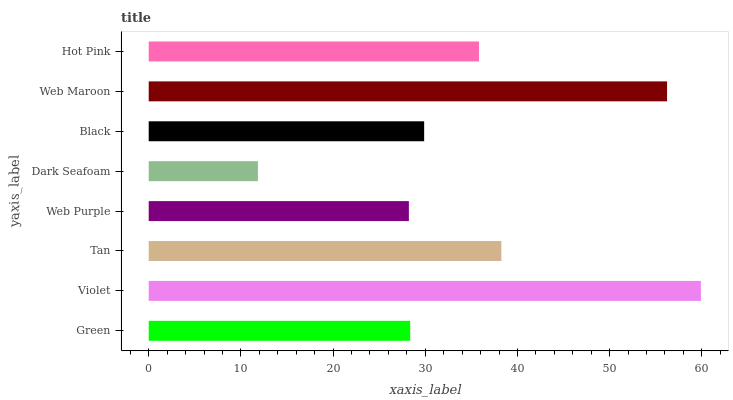Is Dark Seafoam the minimum?
Answer yes or no. Yes. Is Violet the maximum?
Answer yes or no. Yes. Is Tan the minimum?
Answer yes or no. No. Is Tan the maximum?
Answer yes or no. No. Is Violet greater than Tan?
Answer yes or no. Yes. Is Tan less than Violet?
Answer yes or no. Yes. Is Tan greater than Violet?
Answer yes or no. No. Is Violet less than Tan?
Answer yes or no. No. Is Hot Pink the high median?
Answer yes or no. Yes. Is Black the low median?
Answer yes or no. Yes. Is Violet the high median?
Answer yes or no. No. Is Green the low median?
Answer yes or no. No. 